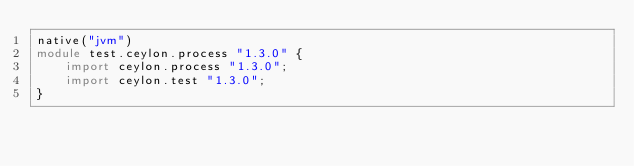<code> <loc_0><loc_0><loc_500><loc_500><_Ceylon_>native("jvm")
module test.ceylon.process "1.3.0" {
    import ceylon.process "1.3.0";
    import ceylon.test "1.3.0";
}
</code> 